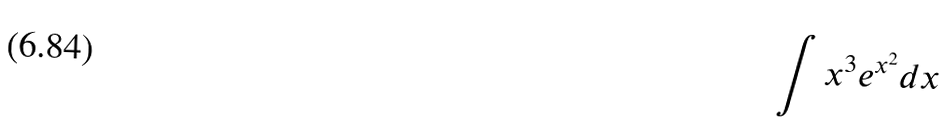Convert formula to latex. <formula><loc_0><loc_0><loc_500><loc_500>\int x ^ { 3 } e ^ { x ^ { 2 } } d x</formula> 